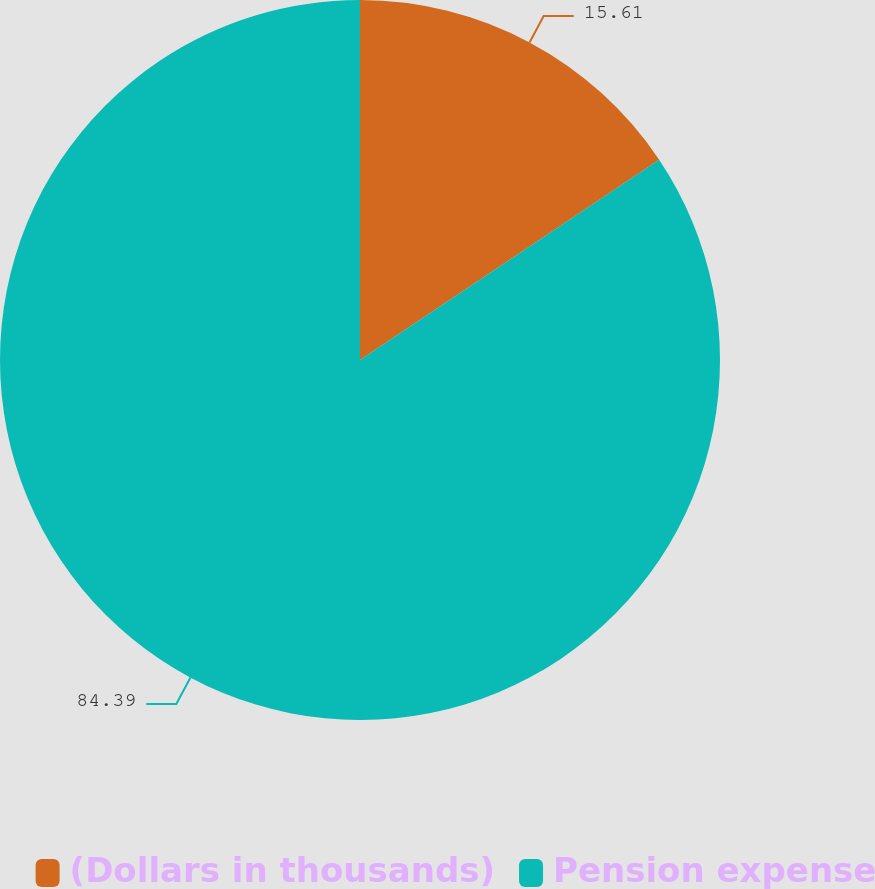<chart> <loc_0><loc_0><loc_500><loc_500><pie_chart><fcel>(Dollars in thousands)<fcel>Pension expense<nl><fcel>15.61%<fcel>84.39%<nl></chart> 